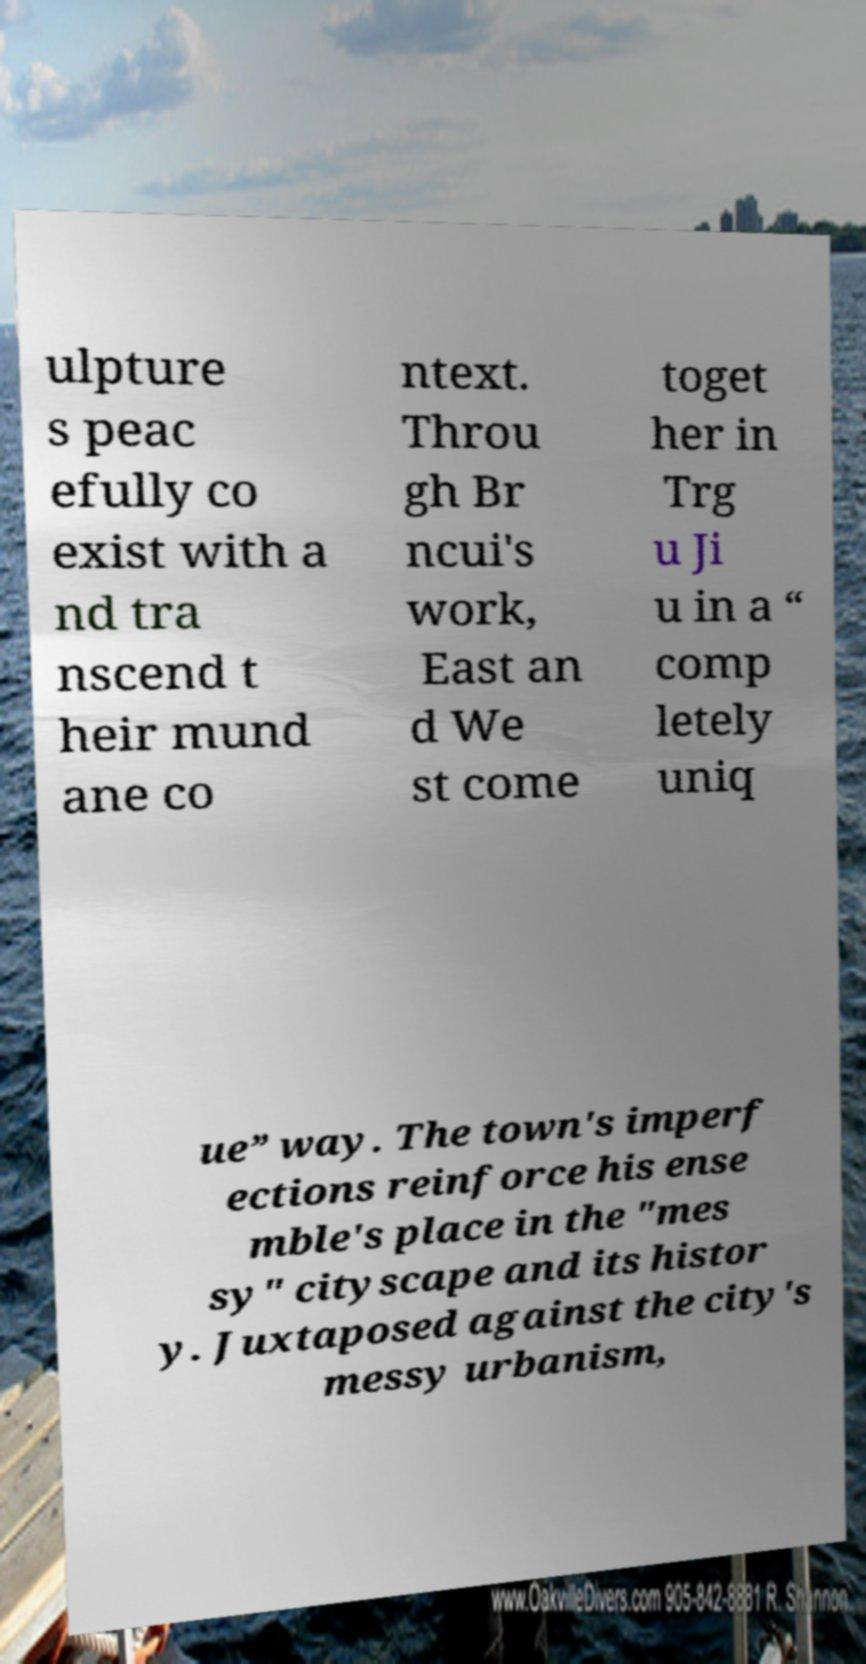For documentation purposes, I need the text within this image transcribed. Could you provide that? ulpture s peac efully co exist with a nd tra nscend t heir mund ane co ntext. Throu gh Br ncui's work, East an d We st come toget her in Trg u Ji u in a “ comp letely uniq ue” way. The town's imperf ections reinforce his ense mble's place in the "mes sy" cityscape and its histor y. Juxtaposed against the city's messy urbanism, 